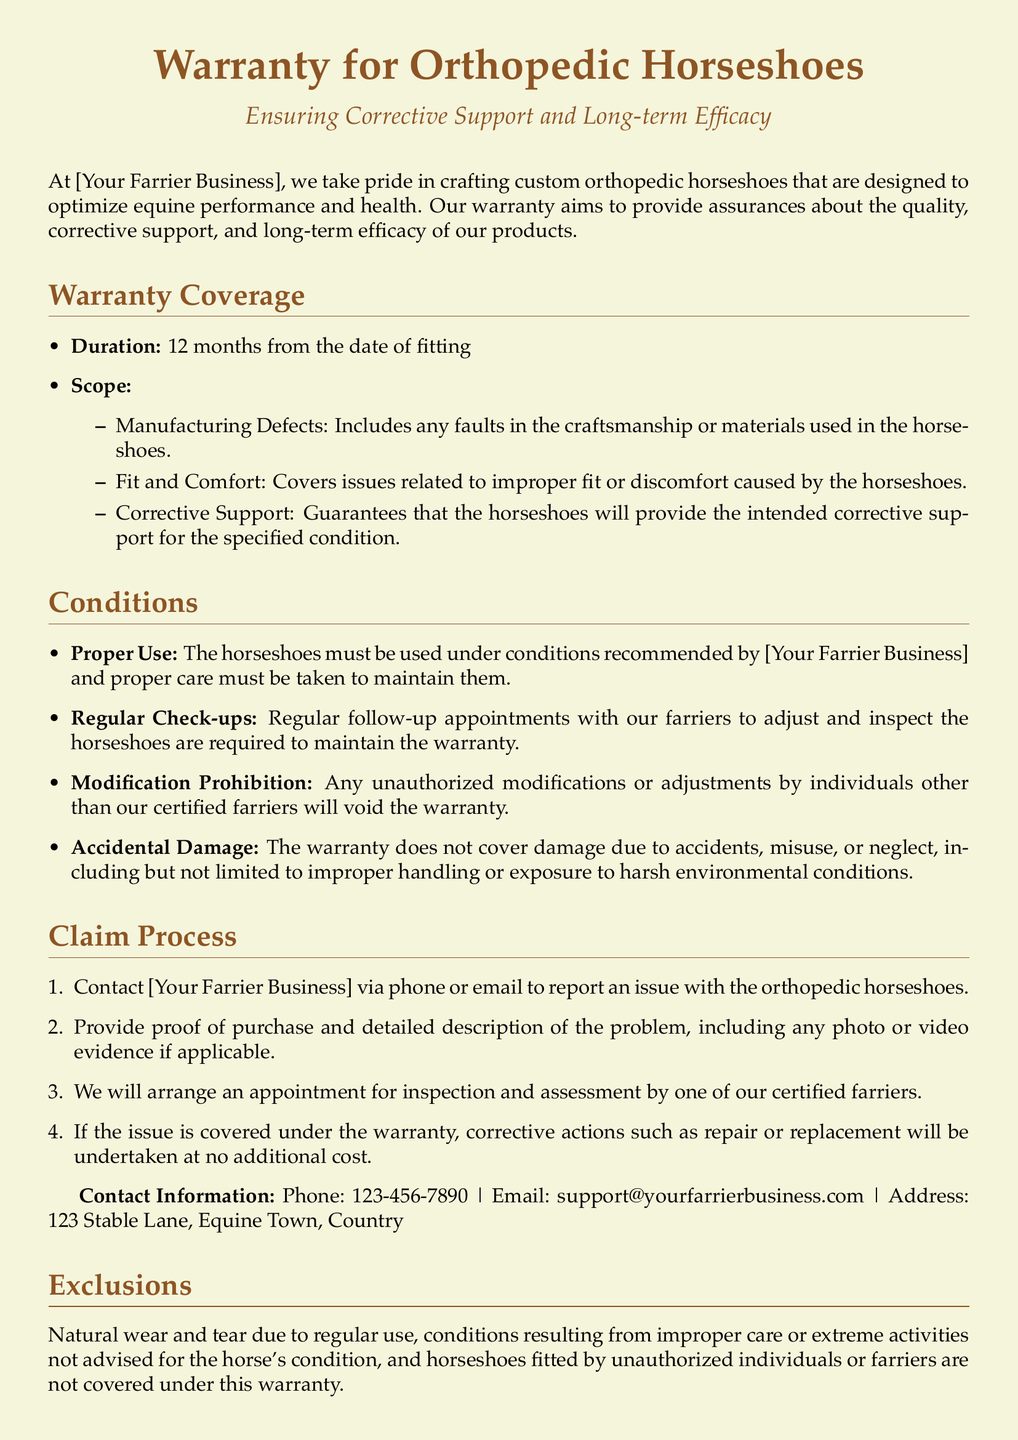What is the duration of the warranty? The warranty lasts for a set period from the date of fitting, which is specified as 12 months.
Answer: 12 months What does the warranty cover regarding fit? The warranty includes specific coverage regarding issues related to the fit and comfort of the horseshoes, ensuring they do not cause discomfort.
Answer: Fit and Comfort What must be done to maintain the warranty? The document states that regular follow-up appointments with the farriers are required to keep the warranty valid.
Answer: Regular Check-ups What happens if the horseshoes are modified? The document indicates that any unauthorized modifications will void the warranty, which means it no longer applies.
Answer: Void the warranty What should be provided when reporting an issue? The warranty claim process states that proof of purchase and a detailed description of the problem must be given when contacting support.
Answer: Proof of purchase What is excluded from the warranty coverage? The document lists certain exclusions to the warranty coverage, specifically mentioning regular wear and tear as one of the factors not covered.
Answer: Natural wear and tear What is the liability limit under this warranty? The document specifies that the liability under this warranty is limited, which means it is restricted to certain actions like repairs or replacements.
Answer: Repair or replacement Who certifies the orthopedic horseshoes? The text mentions that expert farriers certify all the horseshoes, ensuring they meet quality standards.
Answer: Expert farriers What type of damage is not covered by the warranty? The document clearly states that accidental damage is not covered, indicating a specific type of loss that falls outside the warranty terms.
Answer: Accidental damage 